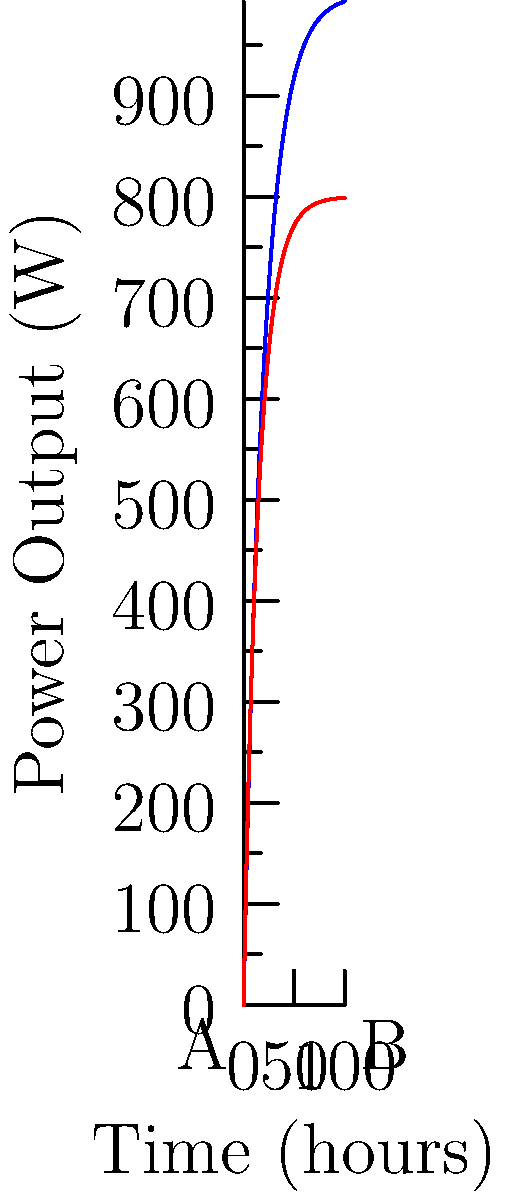Based on the graph showing power output over time for fixed and tracking solar panels on a spacecraft, at which point (A or B) would you recommend switching from fixed panels to tracking panels to optimize power generation efficiency? To determine the optimal point to switch from fixed to tracking solar panels, we need to analyze the power output curves:

1. The blue curve represents fixed panels, while the red curve represents tracking panels.
2. Initially, fixed panels produce more power, but tracking panels eventually surpass them.
3. The intersection point of the two curves is the optimal switching point.
4. This point occurs when:

   $$1000(1-e^{-x/20}) = 800(1-e^{-x/15})$$

5. Solving this equation numerically gives us x ≈ 23.1 hours.
6. Point A (bottom-left) represents the start (0 hours), while point B (bottom-right) represents 100 hours.
7. The optimal switching point (23.1 hours) is closer to A than B.

Therefore, switching from fixed to tracking panels should occur closer to point A for optimal power generation efficiency.
Answer: A 